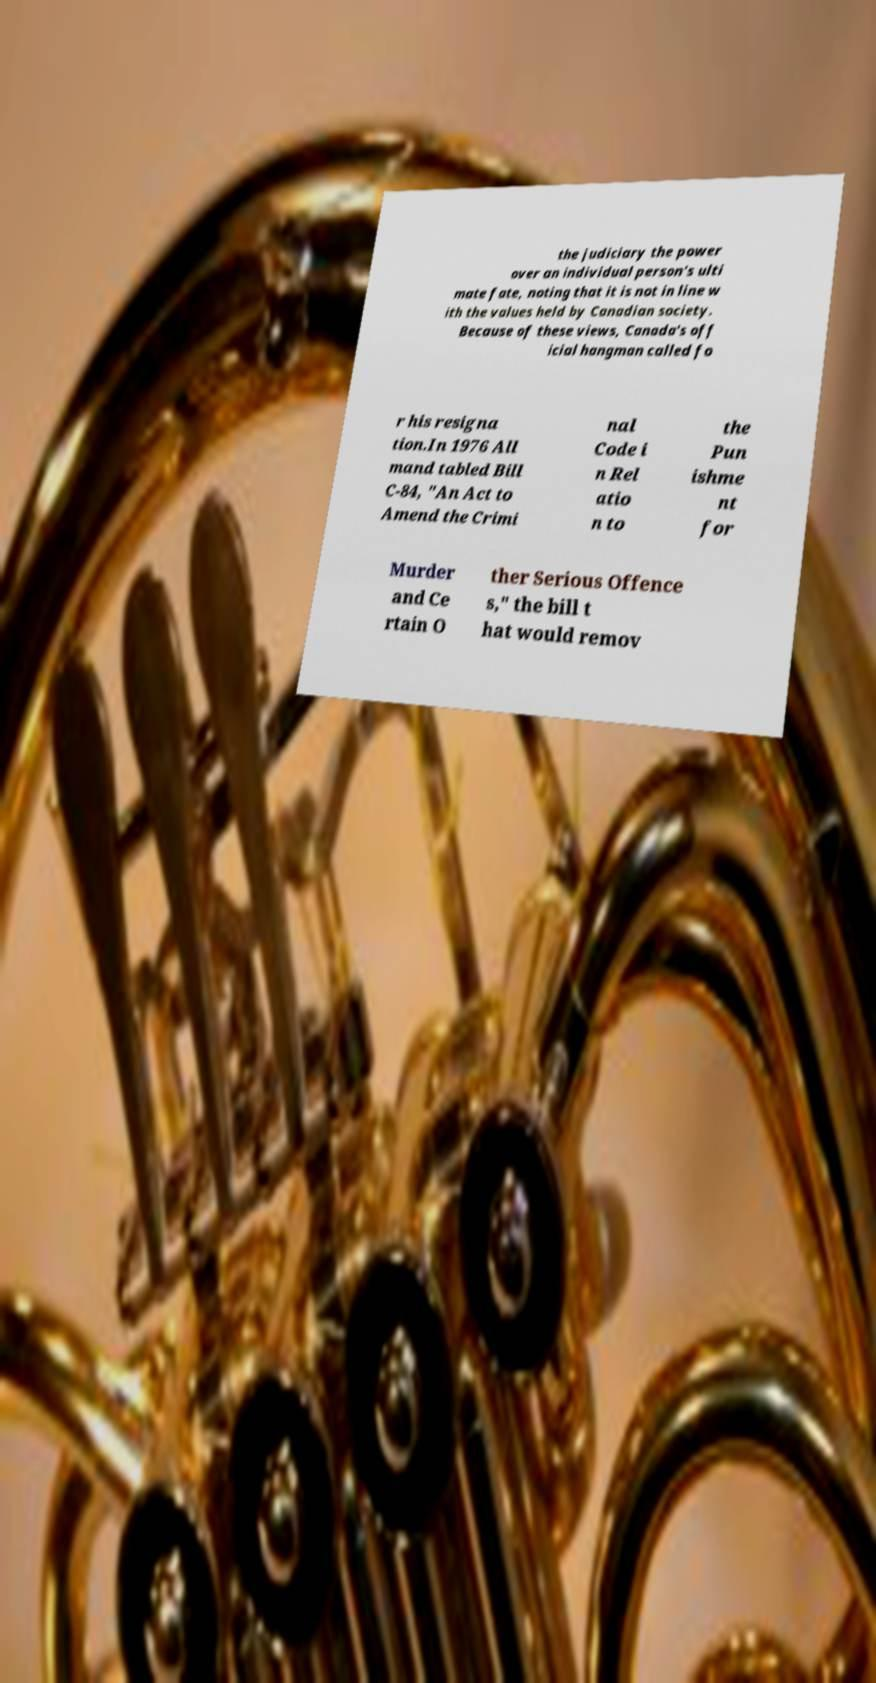Can you accurately transcribe the text from the provided image for me? the judiciary the power over an individual person's ulti mate fate, noting that it is not in line w ith the values held by Canadian society. Because of these views, Canada's off icial hangman called fo r his resigna tion.In 1976 All mand tabled Bill C-84, "An Act to Amend the Crimi nal Code i n Rel atio n to the Pun ishme nt for Murder and Ce rtain O ther Serious Offence s," the bill t hat would remov 